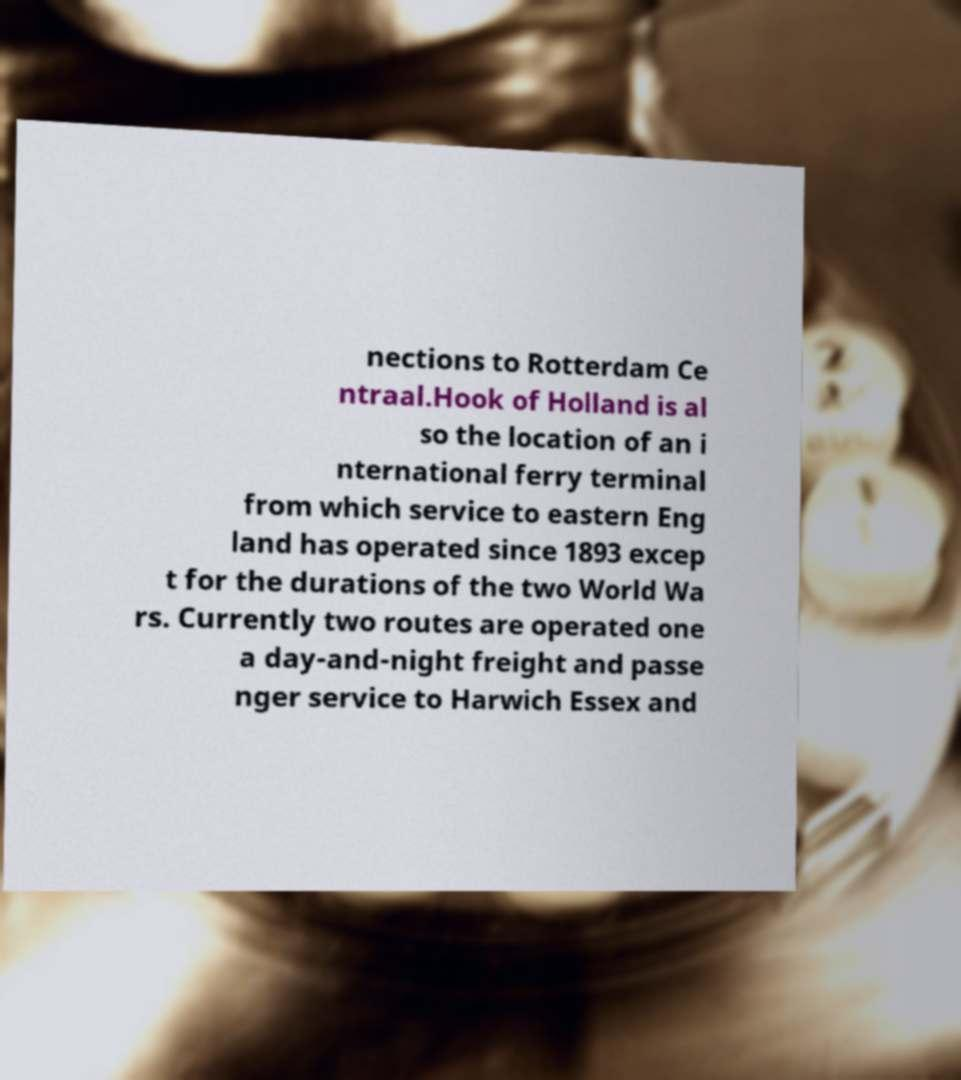Could you extract and type out the text from this image? nections to Rotterdam Ce ntraal.Hook of Holland is al so the location of an i nternational ferry terminal from which service to eastern Eng land has operated since 1893 excep t for the durations of the two World Wa rs. Currently two routes are operated one a day-and-night freight and passe nger service to Harwich Essex and 